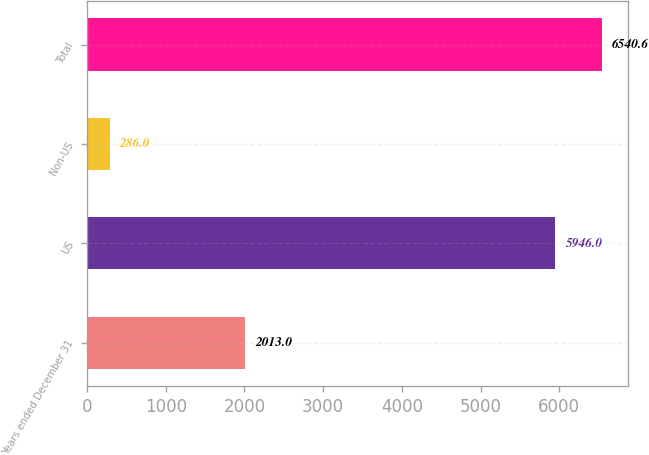<chart> <loc_0><loc_0><loc_500><loc_500><bar_chart><fcel>Years ended December 31<fcel>US<fcel>Non-US<fcel>Total<nl><fcel>2013<fcel>5946<fcel>286<fcel>6540.6<nl></chart> 